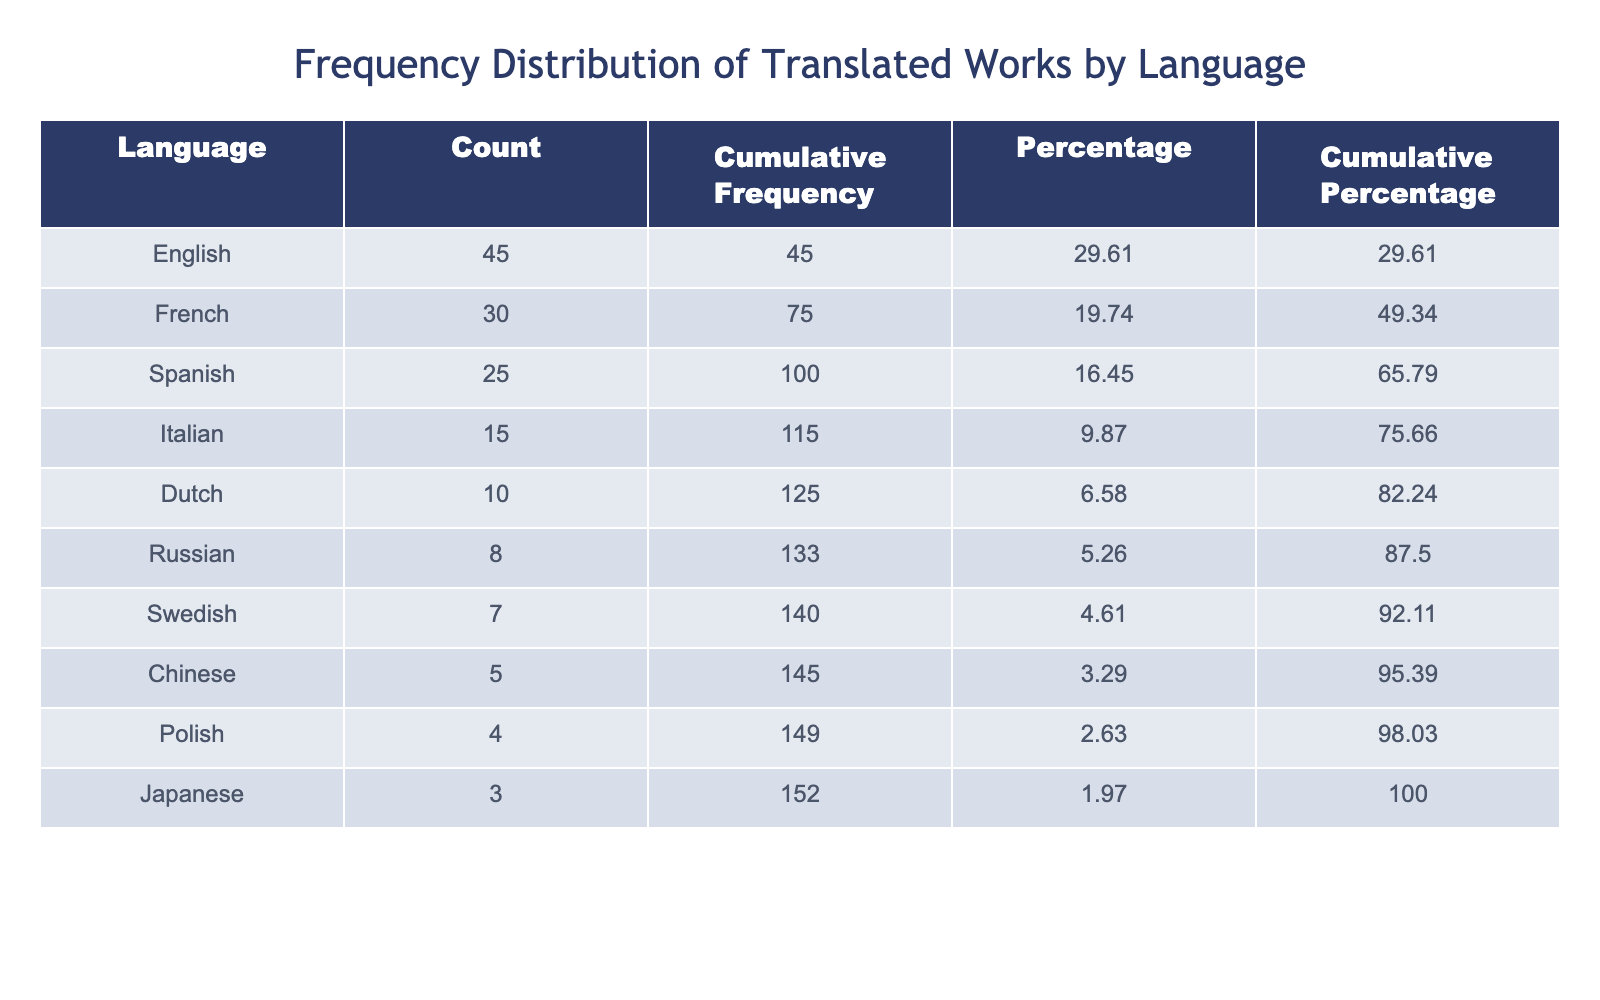What is the total count of translated works? To find the total count, sum all the values in the "Count of Translated Works" column: 45 + 30 + 25 + 15 + 10 + 8 + 5 + 3 + 7 + 4 =  3 + 36 + 25 + 15 + 10 =  30 + 15 + 10 + 8 + 5 + 3 + 7 + 4 =  73 + 25 + 15 =  73 + 25 = 119. So, the total is 119.
Answer: 119 Which language has the highest count of translated works? By inspecting the table, the language with the highest count of translated works is English, which has a count of 45.
Answer: English Is there a significant difference between the count of translated works for English and French? The difference between the counts for English (45) and French (30) is calculated as 45 - 30 = 15. Since 15 is notable and represents a significant gap, the answer is yes.
Answer: Yes What percentage of the total translated works does Japanese represent? First, we find the percentage of translated works for Japanese (3) compared to the total (119). Calculation: (3 / 119) * 100 ≈ 2.52. Therefore, Japanese represents approximately 2.52% of the total.
Answer: 2.52% What is the cumulative frequency for the top three languages? First, we look at the counts for English (45), French (30), and Spanish (25). The cumulative frequency is calculated as: 45 + 30 + 25 = 100. Therefore, the cumulative frequency for the top three languages is 100.
Answer: 100 Are there more translated works in Spanish than in Russian? From the table, Spanish has 25 translated works and Russian has 8. Since 25 is greater than 8, the answer is yes.
Answer: Yes What is the average count of translated works for languages outside the top three? The languages outside the top three (Italian, Dutch, Russian, Chinese, Japanese, Swedish, Polish) have counts of 15, 10, 8, 5, 3, 7, and 4, respectively. Summing these gives 15 + 10 + 8 + 5 + 3 + 7 + 4 = 52, and there are 7 languages. Average is 52 / 7 ≈ 7.43.
Answer: 7.43 Which language has the least translated works? Looking at the table, Chinese has the least count of translated works with 5.
Answer: Chinese What is the cumulative percentage of translated works for the top four languages? First, we take the counts for the top four languages: English (45), French (30), Spanish (25), and Italian (15). The cumulative count is 45 + 30 + 25 + 15 = 115. The percentage is then (115 / 119) * 100 ≈ 96.64%. So, the cumulative percentage for the top four languages is approximately 96.64%.
Answer: 96.64% 